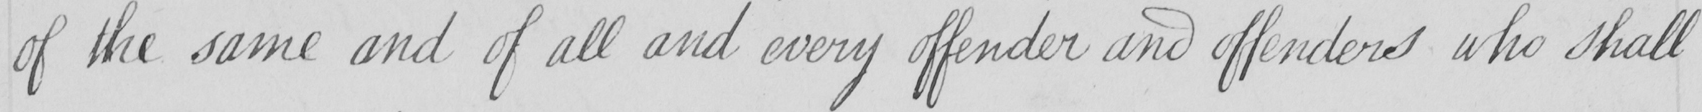What is written in this line of handwriting? of the same and of all and every offender and offenders who shall 